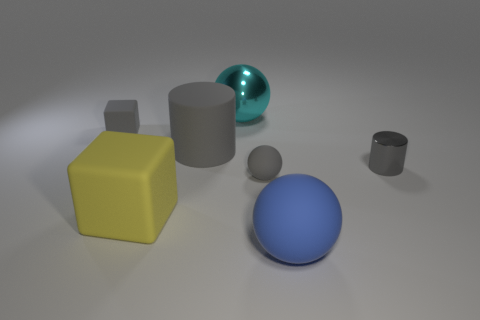Add 1 gray cylinders. How many objects exist? 8 Subtract all cubes. How many objects are left? 5 Add 6 blue rubber spheres. How many blue rubber spheres exist? 7 Subtract 1 yellow cubes. How many objects are left? 6 Subtract all cyan matte cylinders. Subtract all large shiny balls. How many objects are left? 6 Add 2 large metallic balls. How many large metallic balls are left? 3 